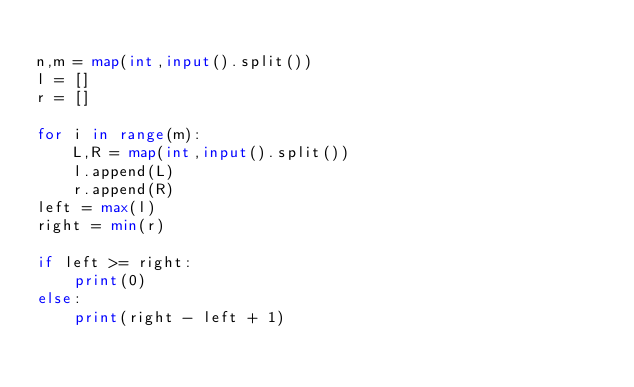Convert code to text. <code><loc_0><loc_0><loc_500><loc_500><_Python_>
n,m = map(int,input().split())
l = []
r = []

for i in range(m):
    L,R = map(int,input().split())
    l.append(L)
    r.append(R)
left = max(l)
right = min(r)

if left >= right:
    print(0)
else:
    print(right - left + 1)
</code> 